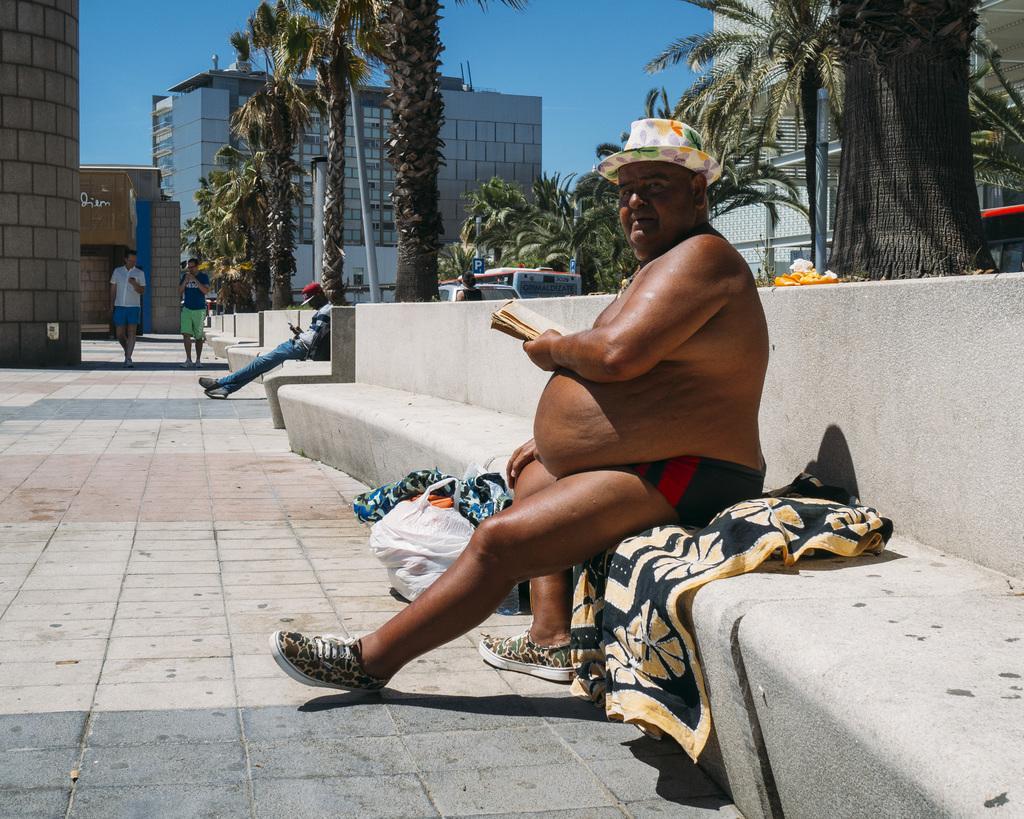How would you summarize this image in a sentence or two? This picture consists of person sitting on bench and in the bench I can see cloth and person holding a book and beside the person I can see a carry bag and clothes and in the middle there are trees, buildings ,poles and the sky visible, in front of tree I can see a bench , on bench I can see a person and two persons walking in front of the building, on the left side I can see building. 